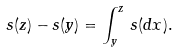<formula> <loc_0><loc_0><loc_500><loc_500>s ( z ) - s ( y ) = \int _ { y } ^ { z } \, s ( d x ) .</formula> 